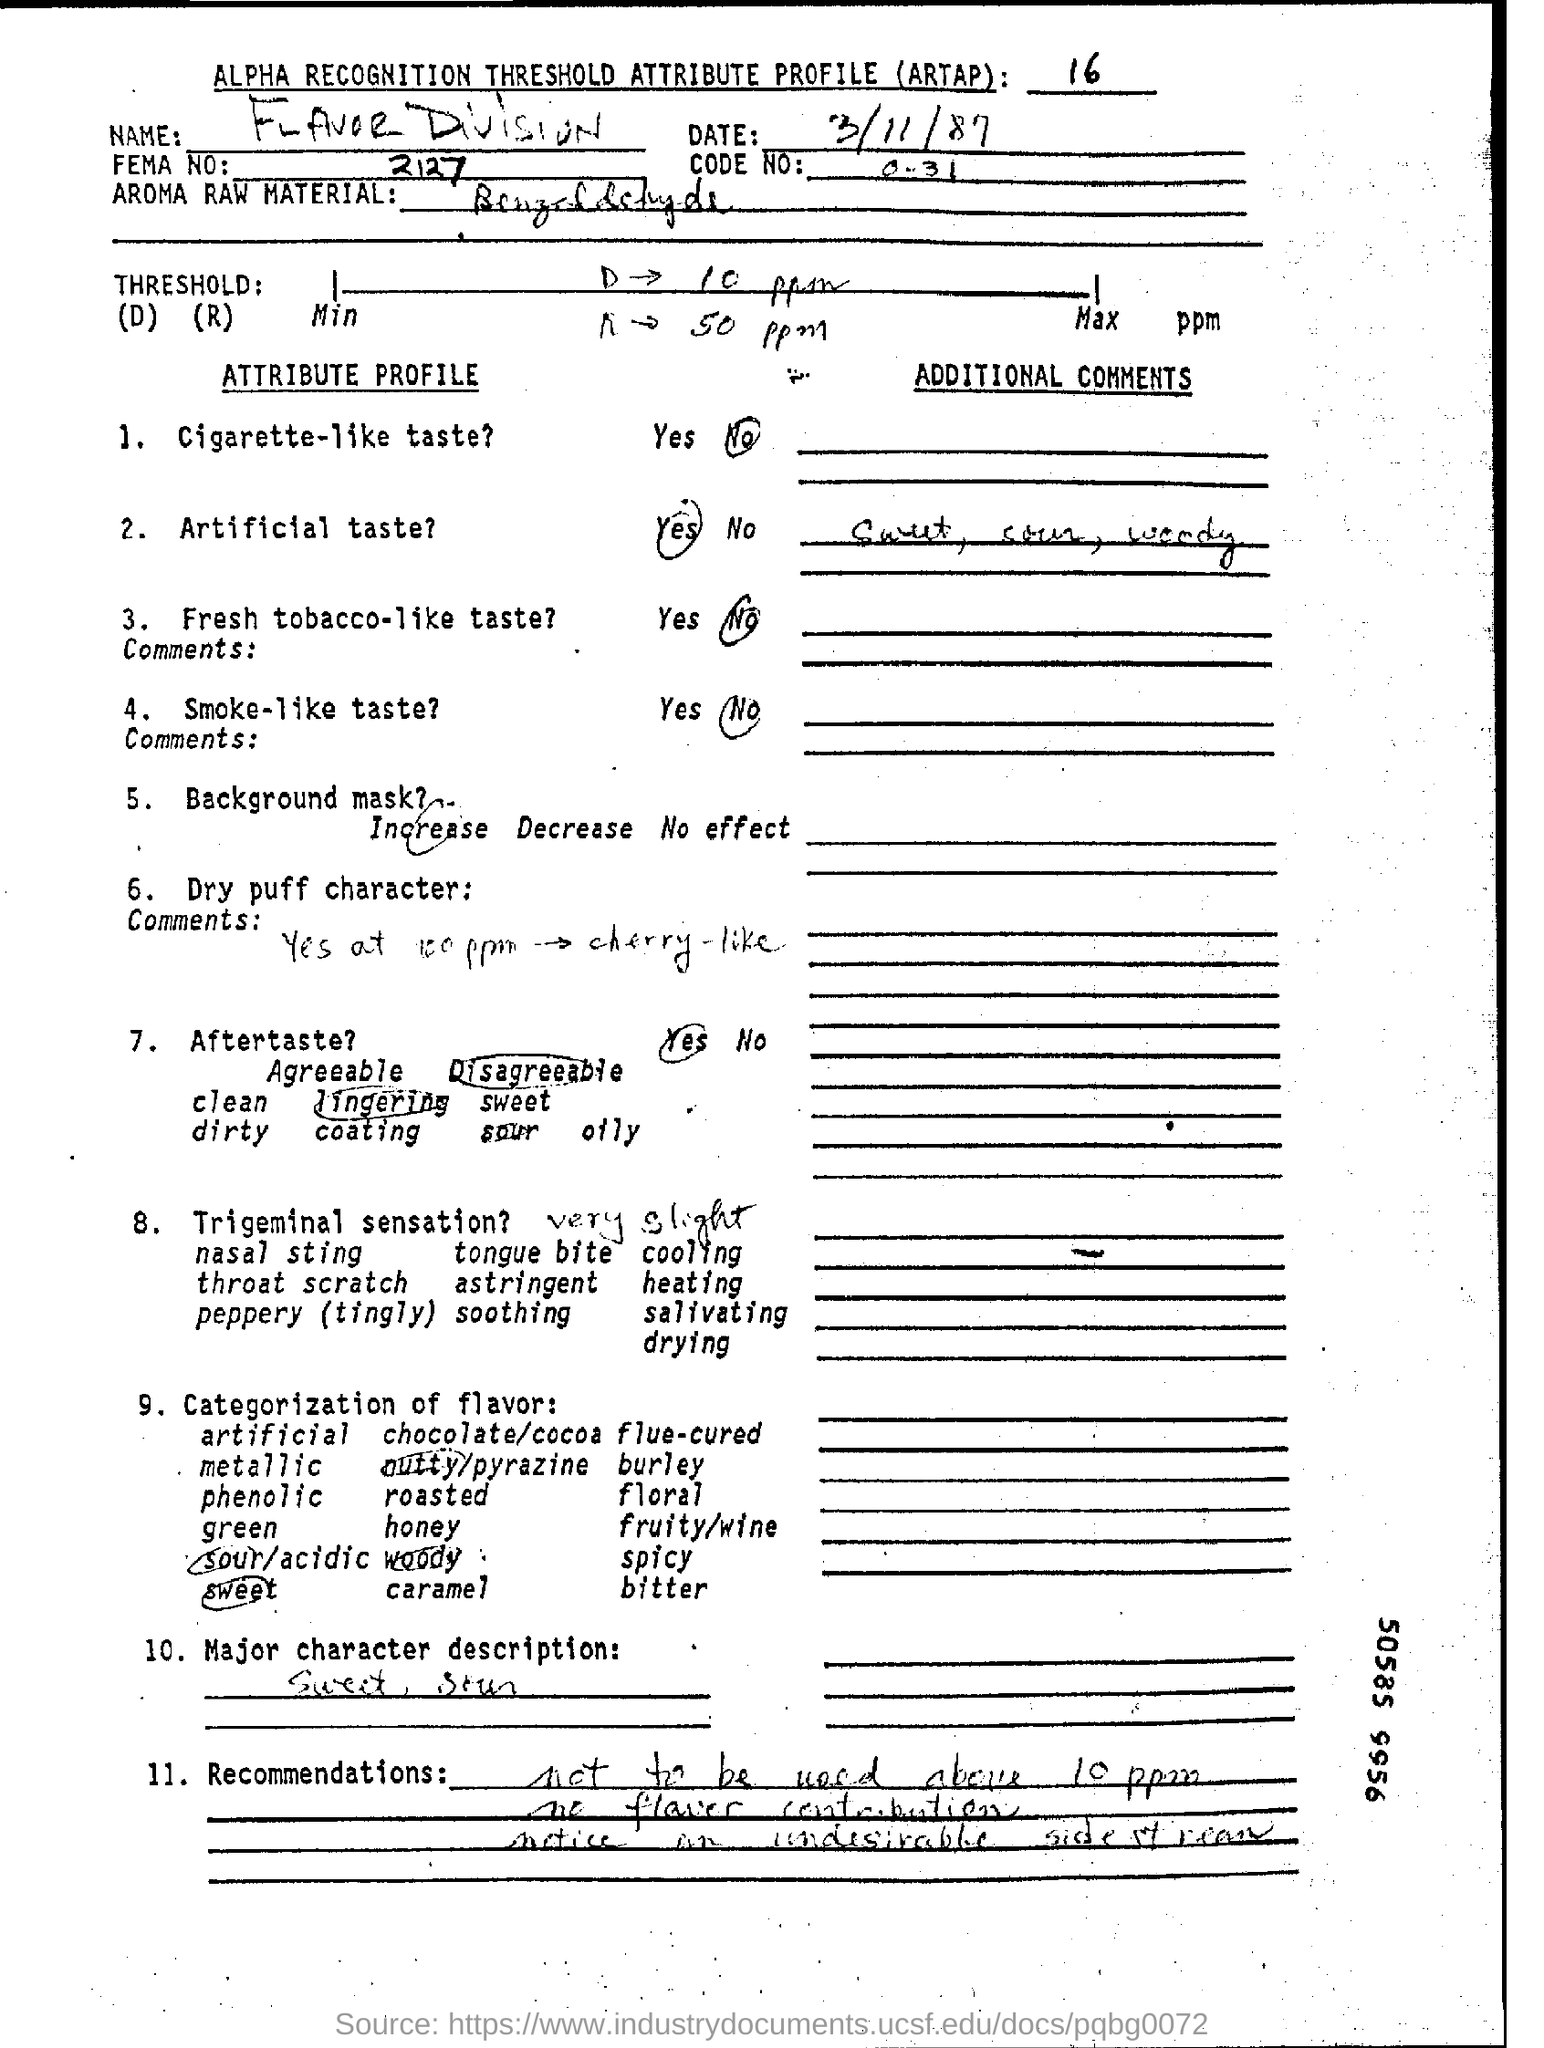Specify some key components in this picture. The code number ranges from 0 to 31, inclusive. The FEMA number is 2127. The date at the top of this document is March 11, 1987. 